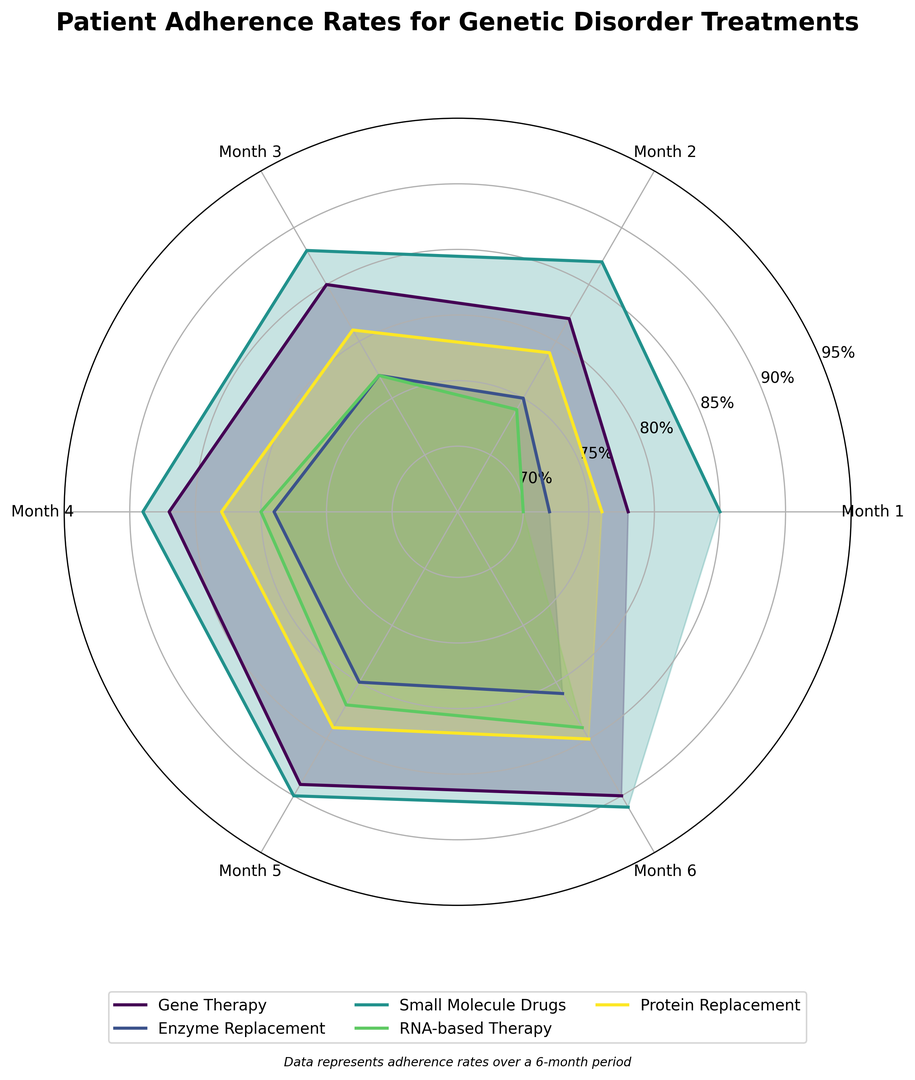Which treatment has the highest adherence rate by Month 6? To find the answer, examine the end points of each treatment's radial line. The treatment with the highest adherence rate at Month 6 is the line that extends the furthest from the center.
Answer: Small Molecule Drugs Which treatment shows the most significant improvement from Month 1 to Month 6? Calculate the increase in adherence rates from Month 1 to Month 6 for each treatment and compare the differences. Gene Therapy improves from 78% to 90% (12%), Enzyme Replacement from 72% to 81% (9%), Small Molecule Drugs from 85% to 91% (6%), RNA-based Therapy from 70% to 84% (14%), and Protein Replacement from 76% to 85% (9%).
Answer: RNA-based Therapy By Month 3, which treatment has the lowest adherence rate? Look at the radial length for each treatment at the angle corresponding to Month 3 and identify the shortest line.
Answer: Enzyme Replacement What is the average adherence rate of Gene Therapy across all six months? Sum the adherence rates for Gene Therapy across all six months (78 + 82 + 85 + 87 + 89 + 90 = 511), and divide by the number of months to get the average (511 / 6).
Answer: 85.17% How does Protein Replacement adherence in Month 2 compare to RNA-based Therapy adherence in Month 4? Compare the lengths of the radial lines for Protein Replacement in Month 2, which is 79%, and RNA-based Therapy in Month 4, which is 80%.
Answer: RNA-based Therapy in Month 4 is 1% higher than Protein Replacement in Month 2 Which treatment has the smallest increase in adherence rates from Month 4 to Month 5? Calculate the change in adherence rates from Month 4 to Month 5 for each treatment: Gene Therapy (87% to 89%), Enzyme Replacement (79% to 80%), Small Molecule Drugs (89% to 90%), RNA-based Therapy (80% to 82%), and Protein Replacement (83% to 84%). The smallest increase is for Enzyme Replacement (1%).
Answer: Enzyme Replacement From Month 1 to Month 6, which treatment remains consistently above 80% adherence? Identify the treatments with adherence rates above 80% for all the months. Small Molecule Drugs (85, 87, 88, 89, 90, 91), Protein Replacement (76, 79, 81, 83, 84, 85) starts below 80% but eventually goes above. Only Small Molecule Drugs fit all the criteria.
Answer: Small Molecule Drugs What is the median adherence rate for Enzyme Replacement across the six months? Arrange the adherence rates for Enzyme Replacement in ascending order (72, 75, 77, 79, 80, 81), then find the middle value. Since there are an even number of values, the median is the average of the 3rd and 4th values ((77 + 79) / 2).
Answer: 78% Is there any treatment with an adherence lower than 71% in any of the months? Inspect the radial lengths for all treatments and check if any of them fall below the 71% mark in any month.
Answer: No 